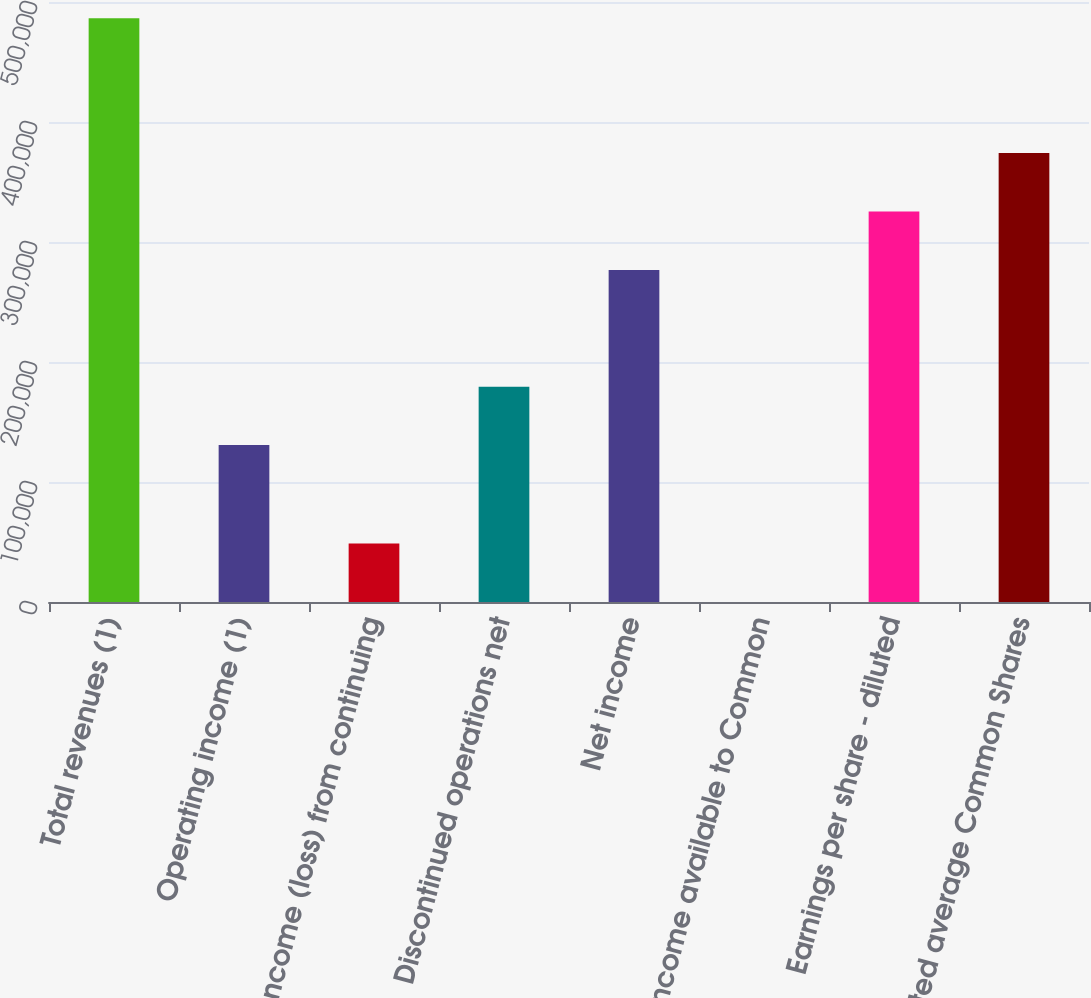<chart> <loc_0><loc_0><loc_500><loc_500><bar_chart><fcel>Total revenues (1)<fcel>Operating income (1)<fcel>Income (loss) from continuing<fcel>Discontinued operations net<fcel>Net income<fcel>Net income available to Common<fcel>Earnings per share - diluted<fcel>Weighted average Common Shares<nl><fcel>486532<fcel>130798<fcel>48653.6<fcel>179451<fcel>276757<fcel>0.48<fcel>325411<fcel>374064<nl></chart> 